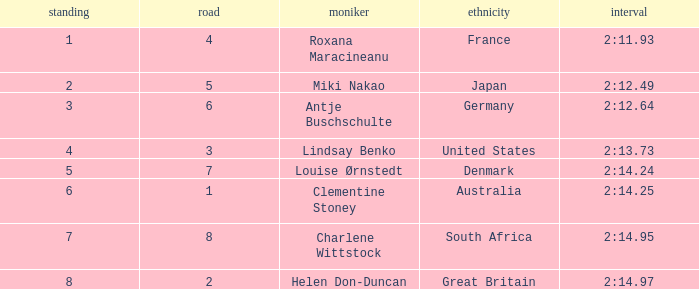What shows for nationality when there is a rank larger than 6, and a Time of 2:14.95? South Africa. 